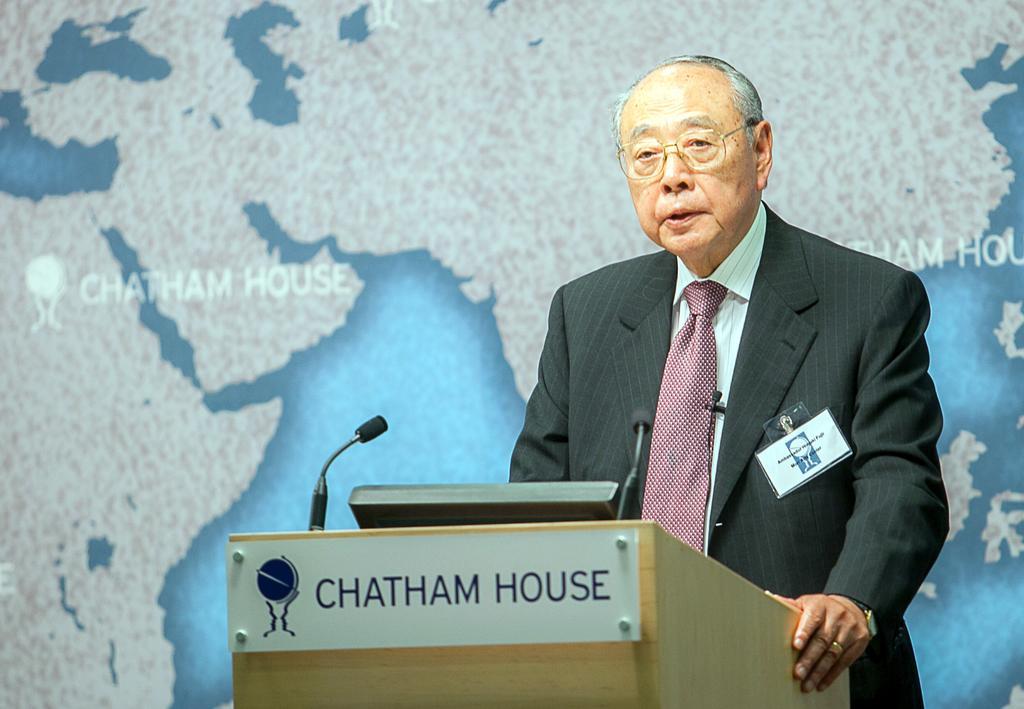How would you summarize this image in a sentence or two? In the image we can see there is a man standing near the podium and there is a mic with a stand. The person is wearing formal suit and behind there is a map on the banner. 